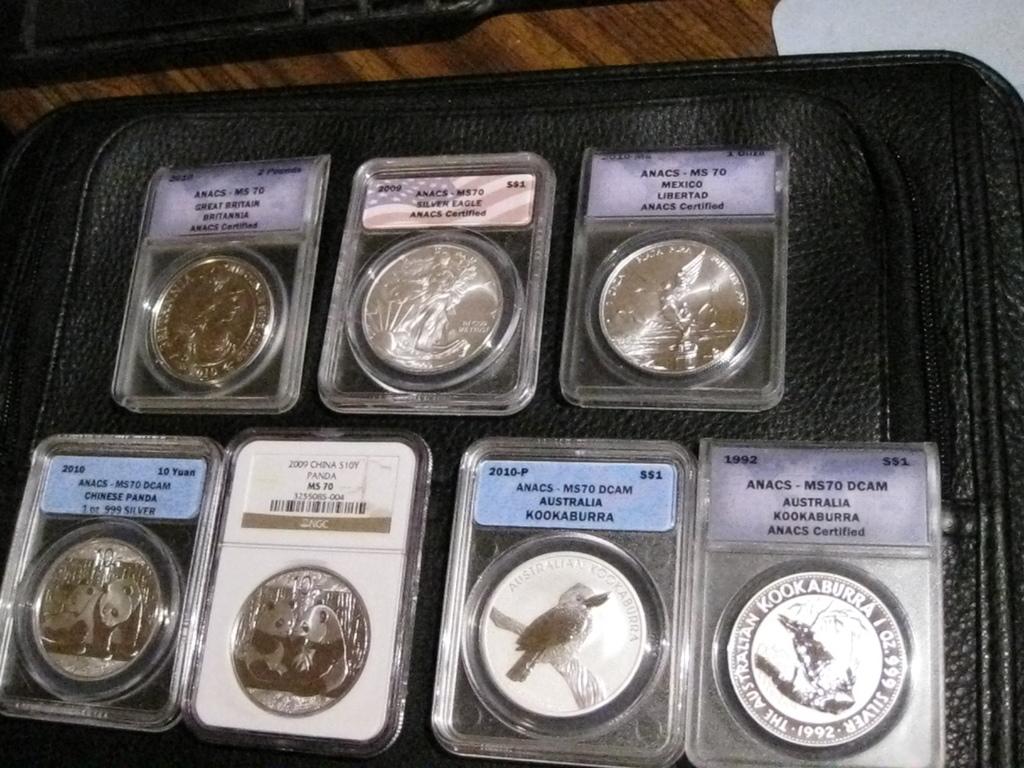Where is the bottom right coin from?
Make the answer very short. Australia. 